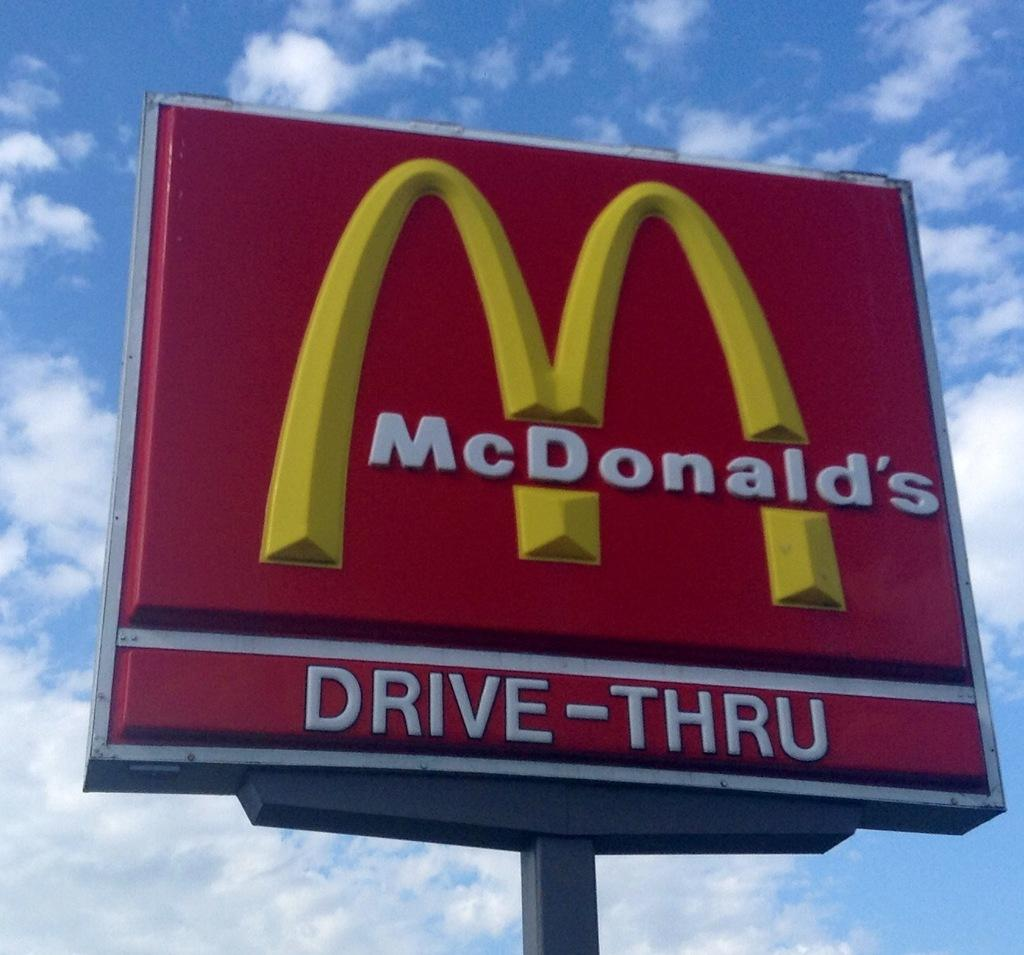<image>
Write a terse but informative summary of the picture. A outdoor red sign for the fast food restaurant "McDonald's". 